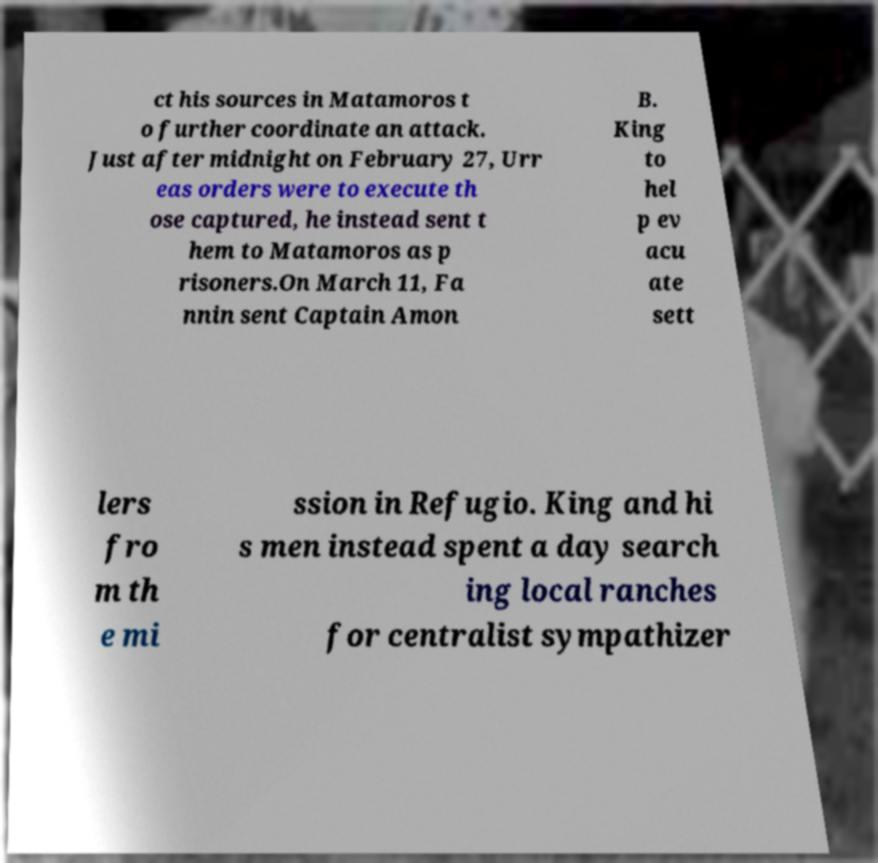There's text embedded in this image that I need extracted. Can you transcribe it verbatim? ct his sources in Matamoros t o further coordinate an attack. Just after midnight on February 27, Urr eas orders were to execute th ose captured, he instead sent t hem to Matamoros as p risoners.On March 11, Fa nnin sent Captain Amon B. King to hel p ev acu ate sett lers fro m th e mi ssion in Refugio. King and hi s men instead spent a day search ing local ranches for centralist sympathizer 